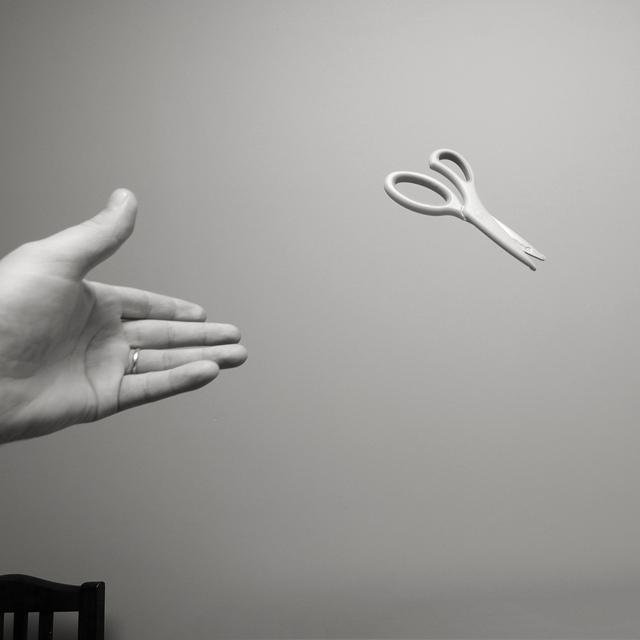How will the scissors move next?

Choices:
A) straight up
B) remain still
C) arc downwards
D) straight down arc downwards 